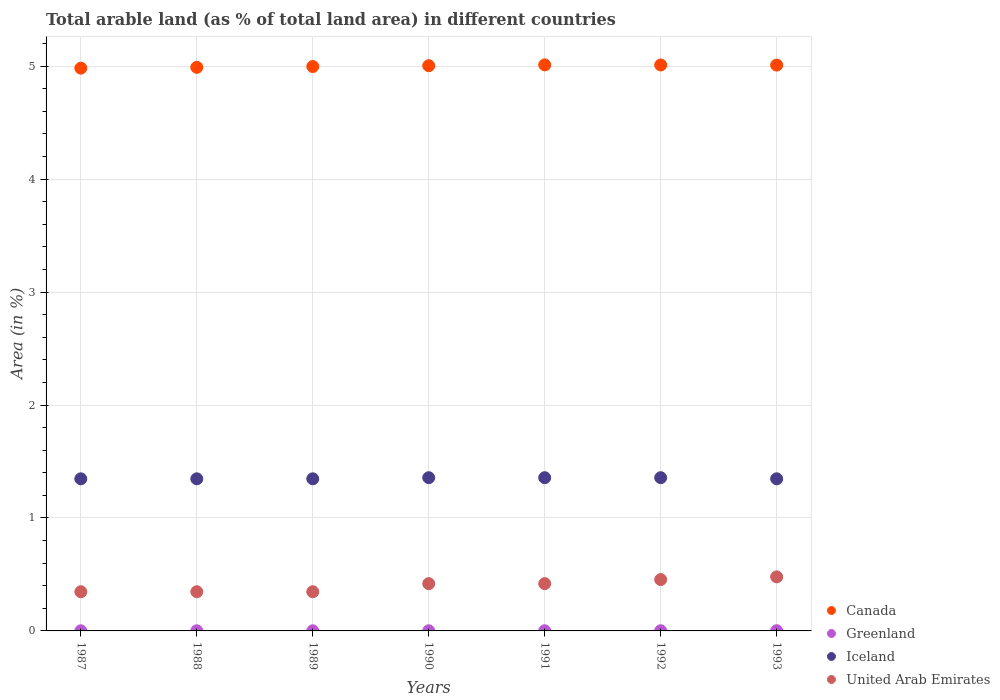How many different coloured dotlines are there?
Make the answer very short. 4. Is the number of dotlines equal to the number of legend labels?
Offer a very short reply. Yes. What is the percentage of arable land in Iceland in 1993?
Make the answer very short. 1.35. Across all years, what is the maximum percentage of arable land in Iceland?
Your answer should be very brief. 1.36. Across all years, what is the minimum percentage of arable land in United Arab Emirates?
Offer a very short reply. 0.35. In which year was the percentage of arable land in United Arab Emirates maximum?
Your response must be concise. 1993. In which year was the percentage of arable land in Canada minimum?
Your answer should be very brief. 1987. What is the total percentage of arable land in Iceland in the graph?
Keep it short and to the point. 9.46. What is the difference between the percentage of arable land in Canada in 1989 and that in 1992?
Keep it short and to the point. -0.01. What is the difference between the percentage of arable land in United Arab Emirates in 1989 and the percentage of arable land in Greenland in 1990?
Give a very brief answer. 0.35. What is the average percentage of arable land in Iceland per year?
Ensure brevity in your answer.  1.35. In the year 1993, what is the difference between the percentage of arable land in Greenland and percentage of arable land in Canada?
Provide a short and direct response. -5.01. In how many years, is the percentage of arable land in United Arab Emirates greater than 1.8 %?
Keep it short and to the point. 0. What is the ratio of the percentage of arable land in United Arab Emirates in 1989 to that in 1991?
Offer a terse response. 0.83. Is the difference between the percentage of arable land in Greenland in 1987 and 1989 greater than the difference between the percentage of arable land in Canada in 1987 and 1989?
Your response must be concise. Yes. What is the difference between the highest and the lowest percentage of arable land in Iceland?
Give a very brief answer. 0.01. Is it the case that in every year, the sum of the percentage of arable land in Canada and percentage of arable land in Iceland  is greater than the sum of percentage of arable land in United Arab Emirates and percentage of arable land in Greenland?
Your answer should be very brief. No. Does the percentage of arable land in Canada monotonically increase over the years?
Your answer should be compact. No. Is the percentage of arable land in Canada strictly less than the percentage of arable land in United Arab Emirates over the years?
Make the answer very short. No. How many years are there in the graph?
Your response must be concise. 7. What is the difference between two consecutive major ticks on the Y-axis?
Provide a short and direct response. 1. Are the values on the major ticks of Y-axis written in scientific E-notation?
Make the answer very short. No. Does the graph contain any zero values?
Your answer should be very brief. No. Does the graph contain grids?
Your response must be concise. Yes. What is the title of the graph?
Offer a very short reply. Total arable land (as % of total land area) in different countries. Does "High income: nonOECD" appear as one of the legend labels in the graph?
Offer a very short reply. No. What is the label or title of the X-axis?
Keep it short and to the point. Years. What is the label or title of the Y-axis?
Offer a very short reply. Area (in %). What is the Area (in %) of Canada in 1987?
Your response must be concise. 4.98. What is the Area (in %) in Greenland in 1987?
Your answer should be very brief. 0. What is the Area (in %) in Iceland in 1987?
Your answer should be compact. 1.35. What is the Area (in %) in United Arab Emirates in 1987?
Provide a succinct answer. 0.35. What is the Area (in %) in Canada in 1988?
Offer a terse response. 4.99. What is the Area (in %) in Greenland in 1988?
Provide a short and direct response. 0. What is the Area (in %) of Iceland in 1988?
Keep it short and to the point. 1.35. What is the Area (in %) in United Arab Emirates in 1988?
Make the answer very short. 0.35. What is the Area (in %) of Canada in 1989?
Make the answer very short. 5. What is the Area (in %) in Greenland in 1989?
Offer a terse response. 0. What is the Area (in %) in Iceland in 1989?
Your answer should be compact. 1.35. What is the Area (in %) in United Arab Emirates in 1989?
Give a very brief answer. 0.35. What is the Area (in %) of Canada in 1990?
Your answer should be compact. 5. What is the Area (in %) of Greenland in 1990?
Keep it short and to the point. 0. What is the Area (in %) in Iceland in 1990?
Ensure brevity in your answer.  1.36. What is the Area (in %) in United Arab Emirates in 1990?
Offer a terse response. 0.42. What is the Area (in %) in Canada in 1991?
Your answer should be compact. 5.01. What is the Area (in %) of Greenland in 1991?
Offer a terse response. 0. What is the Area (in %) in Iceland in 1991?
Keep it short and to the point. 1.36. What is the Area (in %) of United Arab Emirates in 1991?
Keep it short and to the point. 0.42. What is the Area (in %) of Canada in 1992?
Your response must be concise. 5.01. What is the Area (in %) in Greenland in 1992?
Provide a succinct answer. 0. What is the Area (in %) in Iceland in 1992?
Keep it short and to the point. 1.36. What is the Area (in %) of United Arab Emirates in 1992?
Make the answer very short. 0.45. What is the Area (in %) of Canada in 1993?
Your answer should be compact. 5.01. What is the Area (in %) of Greenland in 1993?
Your answer should be compact. 0. What is the Area (in %) of Iceland in 1993?
Provide a short and direct response. 1.35. What is the Area (in %) of United Arab Emirates in 1993?
Your response must be concise. 0.48. Across all years, what is the maximum Area (in %) of Canada?
Offer a terse response. 5.01. Across all years, what is the maximum Area (in %) in Greenland?
Provide a short and direct response. 0. Across all years, what is the maximum Area (in %) of Iceland?
Keep it short and to the point. 1.36. Across all years, what is the maximum Area (in %) of United Arab Emirates?
Your answer should be very brief. 0.48. Across all years, what is the minimum Area (in %) of Canada?
Your answer should be compact. 4.98. Across all years, what is the minimum Area (in %) of Greenland?
Offer a terse response. 0. Across all years, what is the minimum Area (in %) of Iceland?
Your answer should be very brief. 1.35. Across all years, what is the minimum Area (in %) in United Arab Emirates?
Provide a short and direct response. 0.35. What is the total Area (in %) of Canada in the graph?
Your response must be concise. 35. What is the total Area (in %) in Iceland in the graph?
Offer a terse response. 9.46. What is the total Area (in %) in United Arab Emirates in the graph?
Provide a succinct answer. 2.81. What is the difference between the Area (in %) of Canada in 1987 and that in 1988?
Offer a very short reply. -0.01. What is the difference between the Area (in %) in Greenland in 1987 and that in 1988?
Your response must be concise. 0. What is the difference between the Area (in %) of Canada in 1987 and that in 1989?
Provide a succinct answer. -0.01. What is the difference between the Area (in %) in Greenland in 1987 and that in 1989?
Offer a terse response. 0. What is the difference between the Area (in %) in Iceland in 1987 and that in 1989?
Provide a short and direct response. 0. What is the difference between the Area (in %) of Canada in 1987 and that in 1990?
Ensure brevity in your answer.  -0.02. What is the difference between the Area (in %) in Greenland in 1987 and that in 1990?
Give a very brief answer. -0. What is the difference between the Area (in %) of Iceland in 1987 and that in 1990?
Give a very brief answer. -0.01. What is the difference between the Area (in %) in United Arab Emirates in 1987 and that in 1990?
Give a very brief answer. -0.07. What is the difference between the Area (in %) in Canada in 1987 and that in 1991?
Ensure brevity in your answer.  -0.03. What is the difference between the Area (in %) in Greenland in 1987 and that in 1991?
Offer a terse response. -0. What is the difference between the Area (in %) of Iceland in 1987 and that in 1991?
Provide a succinct answer. -0.01. What is the difference between the Area (in %) of United Arab Emirates in 1987 and that in 1991?
Your answer should be very brief. -0.07. What is the difference between the Area (in %) of Canada in 1987 and that in 1992?
Offer a terse response. -0.03. What is the difference between the Area (in %) in Greenland in 1987 and that in 1992?
Your answer should be compact. -0. What is the difference between the Area (in %) of Iceland in 1987 and that in 1992?
Offer a terse response. -0.01. What is the difference between the Area (in %) in United Arab Emirates in 1987 and that in 1992?
Provide a short and direct response. -0.11. What is the difference between the Area (in %) in Canada in 1987 and that in 1993?
Your response must be concise. -0.03. What is the difference between the Area (in %) of Greenland in 1987 and that in 1993?
Provide a succinct answer. -0. What is the difference between the Area (in %) in United Arab Emirates in 1987 and that in 1993?
Ensure brevity in your answer.  -0.13. What is the difference between the Area (in %) in Canada in 1988 and that in 1989?
Your response must be concise. -0.01. What is the difference between the Area (in %) in Iceland in 1988 and that in 1989?
Provide a short and direct response. 0. What is the difference between the Area (in %) of United Arab Emirates in 1988 and that in 1989?
Ensure brevity in your answer.  0. What is the difference between the Area (in %) of Canada in 1988 and that in 1990?
Your answer should be very brief. -0.01. What is the difference between the Area (in %) in Greenland in 1988 and that in 1990?
Provide a succinct answer. -0. What is the difference between the Area (in %) in Iceland in 1988 and that in 1990?
Offer a very short reply. -0.01. What is the difference between the Area (in %) of United Arab Emirates in 1988 and that in 1990?
Provide a succinct answer. -0.07. What is the difference between the Area (in %) in Canada in 1988 and that in 1991?
Your response must be concise. -0.02. What is the difference between the Area (in %) in Greenland in 1988 and that in 1991?
Offer a very short reply. -0. What is the difference between the Area (in %) in Iceland in 1988 and that in 1991?
Your answer should be compact. -0.01. What is the difference between the Area (in %) in United Arab Emirates in 1988 and that in 1991?
Keep it short and to the point. -0.07. What is the difference between the Area (in %) of Canada in 1988 and that in 1992?
Offer a terse response. -0.02. What is the difference between the Area (in %) in Greenland in 1988 and that in 1992?
Offer a very short reply. -0. What is the difference between the Area (in %) of Iceland in 1988 and that in 1992?
Provide a succinct answer. -0.01. What is the difference between the Area (in %) of United Arab Emirates in 1988 and that in 1992?
Give a very brief answer. -0.11. What is the difference between the Area (in %) in Canada in 1988 and that in 1993?
Provide a short and direct response. -0.02. What is the difference between the Area (in %) in Greenland in 1988 and that in 1993?
Offer a very short reply. -0. What is the difference between the Area (in %) of United Arab Emirates in 1988 and that in 1993?
Provide a short and direct response. -0.13. What is the difference between the Area (in %) in Canada in 1989 and that in 1990?
Make the answer very short. -0.01. What is the difference between the Area (in %) in Greenland in 1989 and that in 1990?
Provide a succinct answer. -0. What is the difference between the Area (in %) in Iceland in 1989 and that in 1990?
Provide a short and direct response. -0.01. What is the difference between the Area (in %) of United Arab Emirates in 1989 and that in 1990?
Your answer should be very brief. -0.07. What is the difference between the Area (in %) of Canada in 1989 and that in 1991?
Offer a terse response. -0.01. What is the difference between the Area (in %) in Greenland in 1989 and that in 1991?
Offer a terse response. -0. What is the difference between the Area (in %) of Iceland in 1989 and that in 1991?
Provide a succinct answer. -0.01. What is the difference between the Area (in %) in United Arab Emirates in 1989 and that in 1991?
Your answer should be very brief. -0.07. What is the difference between the Area (in %) of Canada in 1989 and that in 1992?
Provide a short and direct response. -0.01. What is the difference between the Area (in %) of Greenland in 1989 and that in 1992?
Your response must be concise. -0. What is the difference between the Area (in %) of Iceland in 1989 and that in 1992?
Offer a terse response. -0.01. What is the difference between the Area (in %) in United Arab Emirates in 1989 and that in 1992?
Give a very brief answer. -0.11. What is the difference between the Area (in %) in Canada in 1989 and that in 1993?
Offer a very short reply. -0.01. What is the difference between the Area (in %) in Greenland in 1989 and that in 1993?
Your answer should be very brief. -0. What is the difference between the Area (in %) in Iceland in 1989 and that in 1993?
Keep it short and to the point. 0. What is the difference between the Area (in %) in United Arab Emirates in 1989 and that in 1993?
Your answer should be very brief. -0.13. What is the difference between the Area (in %) of Canada in 1990 and that in 1991?
Give a very brief answer. -0.01. What is the difference between the Area (in %) of Greenland in 1990 and that in 1991?
Your response must be concise. 0. What is the difference between the Area (in %) of Canada in 1990 and that in 1992?
Provide a succinct answer. -0.01. What is the difference between the Area (in %) of Greenland in 1990 and that in 1992?
Your answer should be compact. -0. What is the difference between the Area (in %) of Iceland in 1990 and that in 1992?
Your answer should be very brief. 0. What is the difference between the Area (in %) of United Arab Emirates in 1990 and that in 1992?
Your answer should be very brief. -0.04. What is the difference between the Area (in %) in Canada in 1990 and that in 1993?
Make the answer very short. -0.01. What is the difference between the Area (in %) in Greenland in 1990 and that in 1993?
Give a very brief answer. -0. What is the difference between the Area (in %) of Iceland in 1990 and that in 1993?
Offer a terse response. 0.01. What is the difference between the Area (in %) in United Arab Emirates in 1990 and that in 1993?
Provide a short and direct response. -0.06. What is the difference between the Area (in %) in Canada in 1991 and that in 1992?
Your answer should be compact. 0. What is the difference between the Area (in %) in Greenland in 1991 and that in 1992?
Your answer should be compact. -0. What is the difference between the Area (in %) of Iceland in 1991 and that in 1992?
Give a very brief answer. 0. What is the difference between the Area (in %) in United Arab Emirates in 1991 and that in 1992?
Provide a succinct answer. -0.04. What is the difference between the Area (in %) of Canada in 1991 and that in 1993?
Provide a succinct answer. 0. What is the difference between the Area (in %) of Greenland in 1991 and that in 1993?
Your response must be concise. -0. What is the difference between the Area (in %) in United Arab Emirates in 1991 and that in 1993?
Keep it short and to the point. -0.06. What is the difference between the Area (in %) in Canada in 1992 and that in 1993?
Offer a very short reply. 0. What is the difference between the Area (in %) of Greenland in 1992 and that in 1993?
Your answer should be compact. 0. What is the difference between the Area (in %) in United Arab Emirates in 1992 and that in 1993?
Provide a short and direct response. -0.02. What is the difference between the Area (in %) of Canada in 1987 and the Area (in %) of Greenland in 1988?
Offer a terse response. 4.98. What is the difference between the Area (in %) in Canada in 1987 and the Area (in %) in Iceland in 1988?
Make the answer very short. 3.64. What is the difference between the Area (in %) of Canada in 1987 and the Area (in %) of United Arab Emirates in 1988?
Keep it short and to the point. 4.64. What is the difference between the Area (in %) in Greenland in 1987 and the Area (in %) in Iceland in 1988?
Your answer should be very brief. -1.35. What is the difference between the Area (in %) in Greenland in 1987 and the Area (in %) in United Arab Emirates in 1988?
Ensure brevity in your answer.  -0.35. What is the difference between the Area (in %) of Iceland in 1987 and the Area (in %) of United Arab Emirates in 1988?
Give a very brief answer. 1. What is the difference between the Area (in %) in Canada in 1987 and the Area (in %) in Greenland in 1989?
Offer a terse response. 4.98. What is the difference between the Area (in %) of Canada in 1987 and the Area (in %) of Iceland in 1989?
Provide a short and direct response. 3.64. What is the difference between the Area (in %) of Canada in 1987 and the Area (in %) of United Arab Emirates in 1989?
Make the answer very short. 4.64. What is the difference between the Area (in %) in Greenland in 1987 and the Area (in %) in Iceland in 1989?
Offer a very short reply. -1.35. What is the difference between the Area (in %) of Greenland in 1987 and the Area (in %) of United Arab Emirates in 1989?
Your response must be concise. -0.35. What is the difference between the Area (in %) of Canada in 1987 and the Area (in %) of Greenland in 1990?
Offer a terse response. 4.98. What is the difference between the Area (in %) in Canada in 1987 and the Area (in %) in Iceland in 1990?
Your answer should be very brief. 3.63. What is the difference between the Area (in %) of Canada in 1987 and the Area (in %) of United Arab Emirates in 1990?
Your answer should be compact. 4.56. What is the difference between the Area (in %) of Greenland in 1987 and the Area (in %) of Iceland in 1990?
Make the answer very short. -1.36. What is the difference between the Area (in %) in Greenland in 1987 and the Area (in %) in United Arab Emirates in 1990?
Give a very brief answer. -0.42. What is the difference between the Area (in %) in Iceland in 1987 and the Area (in %) in United Arab Emirates in 1990?
Your response must be concise. 0.93. What is the difference between the Area (in %) of Canada in 1987 and the Area (in %) of Greenland in 1991?
Your response must be concise. 4.98. What is the difference between the Area (in %) of Canada in 1987 and the Area (in %) of Iceland in 1991?
Your answer should be compact. 3.63. What is the difference between the Area (in %) in Canada in 1987 and the Area (in %) in United Arab Emirates in 1991?
Your answer should be compact. 4.56. What is the difference between the Area (in %) of Greenland in 1987 and the Area (in %) of Iceland in 1991?
Offer a very short reply. -1.36. What is the difference between the Area (in %) in Greenland in 1987 and the Area (in %) in United Arab Emirates in 1991?
Offer a terse response. -0.42. What is the difference between the Area (in %) of Iceland in 1987 and the Area (in %) of United Arab Emirates in 1991?
Make the answer very short. 0.93. What is the difference between the Area (in %) of Canada in 1987 and the Area (in %) of Greenland in 1992?
Ensure brevity in your answer.  4.98. What is the difference between the Area (in %) of Canada in 1987 and the Area (in %) of Iceland in 1992?
Offer a terse response. 3.63. What is the difference between the Area (in %) in Canada in 1987 and the Area (in %) in United Arab Emirates in 1992?
Make the answer very short. 4.53. What is the difference between the Area (in %) of Greenland in 1987 and the Area (in %) of Iceland in 1992?
Provide a succinct answer. -1.36. What is the difference between the Area (in %) in Greenland in 1987 and the Area (in %) in United Arab Emirates in 1992?
Offer a very short reply. -0.45. What is the difference between the Area (in %) in Iceland in 1987 and the Area (in %) in United Arab Emirates in 1992?
Keep it short and to the point. 0.89. What is the difference between the Area (in %) in Canada in 1987 and the Area (in %) in Greenland in 1993?
Give a very brief answer. 4.98. What is the difference between the Area (in %) of Canada in 1987 and the Area (in %) of Iceland in 1993?
Offer a very short reply. 3.64. What is the difference between the Area (in %) in Canada in 1987 and the Area (in %) in United Arab Emirates in 1993?
Give a very brief answer. 4.5. What is the difference between the Area (in %) of Greenland in 1987 and the Area (in %) of Iceland in 1993?
Provide a succinct answer. -1.35. What is the difference between the Area (in %) of Greenland in 1987 and the Area (in %) of United Arab Emirates in 1993?
Provide a short and direct response. -0.48. What is the difference between the Area (in %) in Iceland in 1987 and the Area (in %) in United Arab Emirates in 1993?
Ensure brevity in your answer.  0.87. What is the difference between the Area (in %) in Canada in 1988 and the Area (in %) in Greenland in 1989?
Your answer should be compact. 4.99. What is the difference between the Area (in %) in Canada in 1988 and the Area (in %) in Iceland in 1989?
Your response must be concise. 3.64. What is the difference between the Area (in %) of Canada in 1988 and the Area (in %) of United Arab Emirates in 1989?
Provide a short and direct response. 4.64. What is the difference between the Area (in %) in Greenland in 1988 and the Area (in %) in Iceland in 1989?
Offer a very short reply. -1.35. What is the difference between the Area (in %) in Greenland in 1988 and the Area (in %) in United Arab Emirates in 1989?
Make the answer very short. -0.35. What is the difference between the Area (in %) of Iceland in 1988 and the Area (in %) of United Arab Emirates in 1989?
Offer a terse response. 1. What is the difference between the Area (in %) in Canada in 1988 and the Area (in %) in Greenland in 1990?
Keep it short and to the point. 4.99. What is the difference between the Area (in %) of Canada in 1988 and the Area (in %) of Iceland in 1990?
Keep it short and to the point. 3.63. What is the difference between the Area (in %) in Canada in 1988 and the Area (in %) in United Arab Emirates in 1990?
Keep it short and to the point. 4.57. What is the difference between the Area (in %) of Greenland in 1988 and the Area (in %) of Iceland in 1990?
Your answer should be very brief. -1.36. What is the difference between the Area (in %) in Greenland in 1988 and the Area (in %) in United Arab Emirates in 1990?
Give a very brief answer. -0.42. What is the difference between the Area (in %) of Iceland in 1988 and the Area (in %) of United Arab Emirates in 1990?
Provide a short and direct response. 0.93. What is the difference between the Area (in %) of Canada in 1988 and the Area (in %) of Greenland in 1991?
Your answer should be compact. 4.99. What is the difference between the Area (in %) of Canada in 1988 and the Area (in %) of Iceland in 1991?
Provide a short and direct response. 3.63. What is the difference between the Area (in %) of Canada in 1988 and the Area (in %) of United Arab Emirates in 1991?
Make the answer very short. 4.57. What is the difference between the Area (in %) of Greenland in 1988 and the Area (in %) of Iceland in 1991?
Give a very brief answer. -1.36. What is the difference between the Area (in %) of Greenland in 1988 and the Area (in %) of United Arab Emirates in 1991?
Your answer should be compact. -0.42. What is the difference between the Area (in %) in Iceland in 1988 and the Area (in %) in United Arab Emirates in 1991?
Your response must be concise. 0.93. What is the difference between the Area (in %) of Canada in 1988 and the Area (in %) of Greenland in 1992?
Your answer should be compact. 4.99. What is the difference between the Area (in %) in Canada in 1988 and the Area (in %) in Iceland in 1992?
Provide a succinct answer. 3.63. What is the difference between the Area (in %) of Canada in 1988 and the Area (in %) of United Arab Emirates in 1992?
Provide a succinct answer. 4.53. What is the difference between the Area (in %) of Greenland in 1988 and the Area (in %) of Iceland in 1992?
Your answer should be compact. -1.36. What is the difference between the Area (in %) in Greenland in 1988 and the Area (in %) in United Arab Emirates in 1992?
Provide a short and direct response. -0.45. What is the difference between the Area (in %) in Iceland in 1988 and the Area (in %) in United Arab Emirates in 1992?
Give a very brief answer. 0.89. What is the difference between the Area (in %) in Canada in 1988 and the Area (in %) in Greenland in 1993?
Your answer should be compact. 4.99. What is the difference between the Area (in %) in Canada in 1988 and the Area (in %) in Iceland in 1993?
Give a very brief answer. 3.64. What is the difference between the Area (in %) of Canada in 1988 and the Area (in %) of United Arab Emirates in 1993?
Keep it short and to the point. 4.51. What is the difference between the Area (in %) of Greenland in 1988 and the Area (in %) of Iceland in 1993?
Your answer should be very brief. -1.35. What is the difference between the Area (in %) in Greenland in 1988 and the Area (in %) in United Arab Emirates in 1993?
Provide a short and direct response. -0.48. What is the difference between the Area (in %) in Iceland in 1988 and the Area (in %) in United Arab Emirates in 1993?
Offer a very short reply. 0.87. What is the difference between the Area (in %) of Canada in 1989 and the Area (in %) of Greenland in 1990?
Ensure brevity in your answer.  5. What is the difference between the Area (in %) in Canada in 1989 and the Area (in %) in Iceland in 1990?
Provide a succinct answer. 3.64. What is the difference between the Area (in %) of Canada in 1989 and the Area (in %) of United Arab Emirates in 1990?
Offer a terse response. 4.58. What is the difference between the Area (in %) in Greenland in 1989 and the Area (in %) in Iceland in 1990?
Give a very brief answer. -1.36. What is the difference between the Area (in %) in Greenland in 1989 and the Area (in %) in United Arab Emirates in 1990?
Provide a succinct answer. -0.42. What is the difference between the Area (in %) in Iceland in 1989 and the Area (in %) in United Arab Emirates in 1990?
Provide a short and direct response. 0.93. What is the difference between the Area (in %) of Canada in 1989 and the Area (in %) of Greenland in 1991?
Offer a very short reply. 5. What is the difference between the Area (in %) of Canada in 1989 and the Area (in %) of Iceland in 1991?
Make the answer very short. 3.64. What is the difference between the Area (in %) of Canada in 1989 and the Area (in %) of United Arab Emirates in 1991?
Your answer should be very brief. 4.58. What is the difference between the Area (in %) in Greenland in 1989 and the Area (in %) in Iceland in 1991?
Give a very brief answer. -1.36. What is the difference between the Area (in %) of Greenland in 1989 and the Area (in %) of United Arab Emirates in 1991?
Give a very brief answer. -0.42. What is the difference between the Area (in %) of Iceland in 1989 and the Area (in %) of United Arab Emirates in 1991?
Keep it short and to the point. 0.93. What is the difference between the Area (in %) in Canada in 1989 and the Area (in %) in Greenland in 1992?
Provide a succinct answer. 5. What is the difference between the Area (in %) in Canada in 1989 and the Area (in %) in Iceland in 1992?
Provide a succinct answer. 3.64. What is the difference between the Area (in %) in Canada in 1989 and the Area (in %) in United Arab Emirates in 1992?
Provide a short and direct response. 4.54. What is the difference between the Area (in %) of Greenland in 1989 and the Area (in %) of Iceland in 1992?
Your response must be concise. -1.36. What is the difference between the Area (in %) of Greenland in 1989 and the Area (in %) of United Arab Emirates in 1992?
Your answer should be compact. -0.45. What is the difference between the Area (in %) in Iceland in 1989 and the Area (in %) in United Arab Emirates in 1992?
Provide a short and direct response. 0.89. What is the difference between the Area (in %) of Canada in 1989 and the Area (in %) of Greenland in 1993?
Provide a succinct answer. 5. What is the difference between the Area (in %) in Canada in 1989 and the Area (in %) in Iceland in 1993?
Ensure brevity in your answer.  3.65. What is the difference between the Area (in %) of Canada in 1989 and the Area (in %) of United Arab Emirates in 1993?
Give a very brief answer. 4.52. What is the difference between the Area (in %) in Greenland in 1989 and the Area (in %) in Iceland in 1993?
Ensure brevity in your answer.  -1.35. What is the difference between the Area (in %) of Greenland in 1989 and the Area (in %) of United Arab Emirates in 1993?
Your response must be concise. -0.48. What is the difference between the Area (in %) in Iceland in 1989 and the Area (in %) in United Arab Emirates in 1993?
Make the answer very short. 0.87. What is the difference between the Area (in %) in Canada in 1990 and the Area (in %) in Greenland in 1991?
Your response must be concise. 5. What is the difference between the Area (in %) of Canada in 1990 and the Area (in %) of Iceland in 1991?
Offer a very short reply. 3.65. What is the difference between the Area (in %) in Canada in 1990 and the Area (in %) in United Arab Emirates in 1991?
Provide a succinct answer. 4.59. What is the difference between the Area (in %) in Greenland in 1990 and the Area (in %) in Iceland in 1991?
Make the answer very short. -1.36. What is the difference between the Area (in %) of Greenland in 1990 and the Area (in %) of United Arab Emirates in 1991?
Offer a terse response. -0.42. What is the difference between the Area (in %) in Iceland in 1990 and the Area (in %) in United Arab Emirates in 1991?
Offer a terse response. 0.94. What is the difference between the Area (in %) of Canada in 1990 and the Area (in %) of Greenland in 1992?
Keep it short and to the point. 5. What is the difference between the Area (in %) of Canada in 1990 and the Area (in %) of Iceland in 1992?
Make the answer very short. 3.65. What is the difference between the Area (in %) of Canada in 1990 and the Area (in %) of United Arab Emirates in 1992?
Provide a succinct answer. 4.55. What is the difference between the Area (in %) in Greenland in 1990 and the Area (in %) in Iceland in 1992?
Offer a terse response. -1.36. What is the difference between the Area (in %) in Greenland in 1990 and the Area (in %) in United Arab Emirates in 1992?
Make the answer very short. -0.45. What is the difference between the Area (in %) of Iceland in 1990 and the Area (in %) of United Arab Emirates in 1992?
Give a very brief answer. 0.9. What is the difference between the Area (in %) in Canada in 1990 and the Area (in %) in Greenland in 1993?
Give a very brief answer. 5. What is the difference between the Area (in %) in Canada in 1990 and the Area (in %) in Iceland in 1993?
Keep it short and to the point. 3.66. What is the difference between the Area (in %) in Canada in 1990 and the Area (in %) in United Arab Emirates in 1993?
Keep it short and to the point. 4.53. What is the difference between the Area (in %) in Greenland in 1990 and the Area (in %) in Iceland in 1993?
Your answer should be very brief. -1.35. What is the difference between the Area (in %) in Greenland in 1990 and the Area (in %) in United Arab Emirates in 1993?
Keep it short and to the point. -0.48. What is the difference between the Area (in %) in Iceland in 1990 and the Area (in %) in United Arab Emirates in 1993?
Offer a terse response. 0.88. What is the difference between the Area (in %) in Canada in 1991 and the Area (in %) in Greenland in 1992?
Your answer should be very brief. 5.01. What is the difference between the Area (in %) in Canada in 1991 and the Area (in %) in Iceland in 1992?
Offer a terse response. 3.65. What is the difference between the Area (in %) in Canada in 1991 and the Area (in %) in United Arab Emirates in 1992?
Ensure brevity in your answer.  4.56. What is the difference between the Area (in %) in Greenland in 1991 and the Area (in %) in Iceland in 1992?
Give a very brief answer. -1.36. What is the difference between the Area (in %) in Greenland in 1991 and the Area (in %) in United Arab Emirates in 1992?
Give a very brief answer. -0.45. What is the difference between the Area (in %) in Iceland in 1991 and the Area (in %) in United Arab Emirates in 1992?
Your answer should be compact. 0.9. What is the difference between the Area (in %) in Canada in 1991 and the Area (in %) in Greenland in 1993?
Provide a short and direct response. 5.01. What is the difference between the Area (in %) in Canada in 1991 and the Area (in %) in Iceland in 1993?
Give a very brief answer. 3.66. What is the difference between the Area (in %) of Canada in 1991 and the Area (in %) of United Arab Emirates in 1993?
Ensure brevity in your answer.  4.53. What is the difference between the Area (in %) in Greenland in 1991 and the Area (in %) in Iceland in 1993?
Ensure brevity in your answer.  -1.35. What is the difference between the Area (in %) of Greenland in 1991 and the Area (in %) of United Arab Emirates in 1993?
Provide a short and direct response. -0.48. What is the difference between the Area (in %) of Iceland in 1991 and the Area (in %) of United Arab Emirates in 1993?
Make the answer very short. 0.88. What is the difference between the Area (in %) of Canada in 1992 and the Area (in %) of Greenland in 1993?
Your response must be concise. 5.01. What is the difference between the Area (in %) in Canada in 1992 and the Area (in %) in Iceland in 1993?
Offer a very short reply. 3.66. What is the difference between the Area (in %) of Canada in 1992 and the Area (in %) of United Arab Emirates in 1993?
Keep it short and to the point. 4.53. What is the difference between the Area (in %) in Greenland in 1992 and the Area (in %) in Iceland in 1993?
Offer a terse response. -1.34. What is the difference between the Area (in %) of Greenland in 1992 and the Area (in %) of United Arab Emirates in 1993?
Offer a very short reply. -0.48. What is the difference between the Area (in %) in Iceland in 1992 and the Area (in %) in United Arab Emirates in 1993?
Offer a very short reply. 0.88. What is the average Area (in %) in Canada per year?
Keep it short and to the point. 5. What is the average Area (in %) in Greenland per year?
Your answer should be compact. 0. What is the average Area (in %) in Iceland per year?
Provide a short and direct response. 1.35. What is the average Area (in %) in United Arab Emirates per year?
Ensure brevity in your answer.  0.4. In the year 1987, what is the difference between the Area (in %) in Canada and Area (in %) in Greenland?
Keep it short and to the point. 4.98. In the year 1987, what is the difference between the Area (in %) in Canada and Area (in %) in Iceland?
Offer a very short reply. 3.64. In the year 1987, what is the difference between the Area (in %) of Canada and Area (in %) of United Arab Emirates?
Your answer should be very brief. 4.64. In the year 1987, what is the difference between the Area (in %) in Greenland and Area (in %) in Iceland?
Keep it short and to the point. -1.35. In the year 1987, what is the difference between the Area (in %) of Greenland and Area (in %) of United Arab Emirates?
Offer a very short reply. -0.35. In the year 1987, what is the difference between the Area (in %) of Iceland and Area (in %) of United Arab Emirates?
Keep it short and to the point. 1. In the year 1988, what is the difference between the Area (in %) in Canada and Area (in %) in Greenland?
Your answer should be compact. 4.99. In the year 1988, what is the difference between the Area (in %) in Canada and Area (in %) in Iceland?
Offer a terse response. 3.64. In the year 1988, what is the difference between the Area (in %) in Canada and Area (in %) in United Arab Emirates?
Give a very brief answer. 4.64. In the year 1988, what is the difference between the Area (in %) in Greenland and Area (in %) in Iceland?
Provide a short and direct response. -1.35. In the year 1988, what is the difference between the Area (in %) of Greenland and Area (in %) of United Arab Emirates?
Ensure brevity in your answer.  -0.35. In the year 1988, what is the difference between the Area (in %) of Iceland and Area (in %) of United Arab Emirates?
Provide a succinct answer. 1. In the year 1989, what is the difference between the Area (in %) in Canada and Area (in %) in Greenland?
Your answer should be compact. 5. In the year 1989, what is the difference between the Area (in %) in Canada and Area (in %) in Iceland?
Your answer should be very brief. 3.65. In the year 1989, what is the difference between the Area (in %) of Canada and Area (in %) of United Arab Emirates?
Your answer should be compact. 4.65. In the year 1989, what is the difference between the Area (in %) in Greenland and Area (in %) in Iceland?
Offer a terse response. -1.35. In the year 1989, what is the difference between the Area (in %) in Greenland and Area (in %) in United Arab Emirates?
Your answer should be compact. -0.35. In the year 1989, what is the difference between the Area (in %) of Iceland and Area (in %) of United Arab Emirates?
Provide a short and direct response. 1. In the year 1990, what is the difference between the Area (in %) of Canada and Area (in %) of Greenland?
Provide a succinct answer. 5. In the year 1990, what is the difference between the Area (in %) in Canada and Area (in %) in Iceland?
Your answer should be compact. 3.65. In the year 1990, what is the difference between the Area (in %) in Canada and Area (in %) in United Arab Emirates?
Ensure brevity in your answer.  4.59. In the year 1990, what is the difference between the Area (in %) in Greenland and Area (in %) in Iceland?
Make the answer very short. -1.36. In the year 1990, what is the difference between the Area (in %) of Greenland and Area (in %) of United Arab Emirates?
Provide a succinct answer. -0.42. In the year 1990, what is the difference between the Area (in %) of Iceland and Area (in %) of United Arab Emirates?
Keep it short and to the point. 0.94. In the year 1991, what is the difference between the Area (in %) of Canada and Area (in %) of Greenland?
Provide a short and direct response. 5.01. In the year 1991, what is the difference between the Area (in %) in Canada and Area (in %) in Iceland?
Give a very brief answer. 3.65. In the year 1991, what is the difference between the Area (in %) in Canada and Area (in %) in United Arab Emirates?
Provide a short and direct response. 4.59. In the year 1991, what is the difference between the Area (in %) in Greenland and Area (in %) in Iceland?
Make the answer very short. -1.36. In the year 1991, what is the difference between the Area (in %) in Greenland and Area (in %) in United Arab Emirates?
Provide a short and direct response. -0.42. In the year 1991, what is the difference between the Area (in %) of Iceland and Area (in %) of United Arab Emirates?
Your response must be concise. 0.94. In the year 1992, what is the difference between the Area (in %) in Canada and Area (in %) in Greenland?
Give a very brief answer. 5.01. In the year 1992, what is the difference between the Area (in %) of Canada and Area (in %) of Iceland?
Provide a short and direct response. 3.65. In the year 1992, what is the difference between the Area (in %) of Canada and Area (in %) of United Arab Emirates?
Offer a very short reply. 4.56. In the year 1992, what is the difference between the Area (in %) of Greenland and Area (in %) of Iceland?
Provide a short and direct response. -1.35. In the year 1992, what is the difference between the Area (in %) of Greenland and Area (in %) of United Arab Emirates?
Offer a very short reply. -0.45. In the year 1992, what is the difference between the Area (in %) in Iceland and Area (in %) in United Arab Emirates?
Give a very brief answer. 0.9. In the year 1993, what is the difference between the Area (in %) in Canada and Area (in %) in Greenland?
Your response must be concise. 5.01. In the year 1993, what is the difference between the Area (in %) of Canada and Area (in %) of Iceland?
Your answer should be compact. 3.66. In the year 1993, what is the difference between the Area (in %) of Canada and Area (in %) of United Arab Emirates?
Your response must be concise. 4.53. In the year 1993, what is the difference between the Area (in %) in Greenland and Area (in %) in Iceland?
Ensure brevity in your answer.  -1.34. In the year 1993, what is the difference between the Area (in %) of Greenland and Area (in %) of United Arab Emirates?
Your answer should be compact. -0.48. In the year 1993, what is the difference between the Area (in %) in Iceland and Area (in %) in United Arab Emirates?
Keep it short and to the point. 0.87. What is the ratio of the Area (in %) of Greenland in 1987 to that in 1988?
Give a very brief answer. 1. What is the ratio of the Area (in %) in Iceland in 1987 to that in 1988?
Offer a very short reply. 1. What is the ratio of the Area (in %) in Canada in 1987 to that in 1989?
Offer a very short reply. 1. What is the ratio of the Area (in %) of Greenland in 1987 to that in 1989?
Provide a short and direct response. 1. What is the ratio of the Area (in %) of Iceland in 1987 to that in 1989?
Give a very brief answer. 1. What is the ratio of the Area (in %) of Greenland in 1987 to that in 1990?
Your answer should be compact. 0.8. What is the ratio of the Area (in %) of United Arab Emirates in 1987 to that in 1990?
Offer a terse response. 0.83. What is the ratio of the Area (in %) in Iceland in 1987 to that in 1991?
Make the answer very short. 0.99. What is the ratio of the Area (in %) in United Arab Emirates in 1987 to that in 1991?
Offer a very short reply. 0.83. What is the ratio of the Area (in %) in Iceland in 1987 to that in 1992?
Make the answer very short. 0.99. What is the ratio of the Area (in %) of United Arab Emirates in 1987 to that in 1992?
Provide a succinct answer. 0.76. What is the ratio of the Area (in %) in Canada in 1987 to that in 1993?
Offer a terse response. 0.99. What is the ratio of the Area (in %) of United Arab Emirates in 1987 to that in 1993?
Give a very brief answer. 0.72. What is the ratio of the Area (in %) of Canada in 1988 to that in 1989?
Your response must be concise. 1. What is the ratio of the Area (in %) in Iceland in 1988 to that in 1989?
Provide a succinct answer. 1. What is the ratio of the Area (in %) of Greenland in 1988 to that in 1990?
Provide a succinct answer. 0.8. What is the ratio of the Area (in %) in Iceland in 1988 to that in 1990?
Your answer should be very brief. 0.99. What is the ratio of the Area (in %) of United Arab Emirates in 1988 to that in 1990?
Provide a short and direct response. 0.83. What is the ratio of the Area (in %) in Canada in 1988 to that in 1991?
Your answer should be very brief. 1. What is the ratio of the Area (in %) in Greenland in 1988 to that in 1991?
Give a very brief answer. 0.8. What is the ratio of the Area (in %) of Iceland in 1988 to that in 1991?
Provide a short and direct response. 0.99. What is the ratio of the Area (in %) in United Arab Emirates in 1988 to that in 1991?
Provide a short and direct response. 0.83. What is the ratio of the Area (in %) in Iceland in 1988 to that in 1992?
Ensure brevity in your answer.  0.99. What is the ratio of the Area (in %) in United Arab Emirates in 1988 to that in 1992?
Your response must be concise. 0.76. What is the ratio of the Area (in %) in Iceland in 1988 to that in 1993?
Offer a very short reply. 1. What is the ratio of the Area (in %) of United Arab Emirates in 1988 to that in 1993?
Ensure brevity in your answer.  0.72. What is the ratio of the Area (in %) in United Arab Emirates in 1989 to that in 1990?
Your response must be concise. 0.83. What is the ratio of the Area (in %) of Iceland in 1989 to that in 1991?
Give a very brief answer. 0.99. What is the ratio of the Area (in %) in United Arab Emirates in 1989 to that in 1991?
Offer a terse response. 0.83. What is the ratio of the Area (in %) in Canada in 1989 to that in 1992?
Provide a short and direct response. 1. What is the ratio of the Area (in %) in United Arab Emirates in 1989 to that in 1992?
Provide a short and direct response. 0.76. What is the ratio of the Area (in %) of Canada in 1989 to that in 1993?
Keep it short and to the point. 1. What is the ratio of the Area (in %) of Greenland in 1989 to that in 1993?
Give a very brief answer. 0.67. What is the ratio of the Area (in %) of United Arab Emirates in 1989 to that in 1993?
Provide a short and direct response. 0.72. What is the ratio of the Area (in %) in Canada in 1990 to that in 1991?
Make the answer very short. 1. What is the ratio of the Area (in %) of Iceland in 1990 to that in 1991?
Ensure brevity in your answer.  1. What is the ratio of the Area (in %) in United Arab Emirates in 1990 to that in 1991?
Provide a short and direct response. 1. What is the ratio of the Area (in %) in Canada in 1990 to that in 1992?
Provide a succinct answer. 1. What is the ratio of the Area (in %) of United Arab Emirates in 1990 to that in 1992?
Offer a very short reply. 0.92. What is the ratio of the Area (in %) of Canada in 1990 to that in 1993?
Offer a very short reply. 1. What is the ratio of the Area (in %) of Greenland in 1990 to that in 1993?
Give a very brief answer. 0.83. What is the ratio of the Area (in %) of Iceland in 1990 to that in 1993?
Keep it short and to the point. 1.01. What is the ratio of the Area (in %) in United Arab Emirates in 1990 to that in 1993?
Keep it short and to the point. 0.88. What is the ratio of the Area (in %) in Canada in 1991 to that in 1992?
Offer a very short reply. 1. What is the ratio of the Area (in %) in United Arab Emirates in 1991 to that in 1992?
Provide a short and direct response. 0.92. What is the ratio of the Area (in %) in Canada in 1991 to that in 1993?
Ensure brevity in your answer.  1. What is the ratio of the Area (in %) in Iceland in 1991 to that in 1993?
Give a very brief answer. 1.01. What is the ratio of the Area (in %) in Canada in 1992 to that in 1993?
Make the answer very short. 1. What is the ratio of the Area (in %) of Iceland in 1992 to that in 1993?
Keep it short and to the point. 1.01. What is the difference between the highest and the second highest Area (in %) in Canada?
Your answer should be very brief. 0. What is the difference between the highest and the second highest Area (in %) of United Arab Emirates?
Your answer should be compact. 0.02. What is the difference between the highest and the lowest Area (in %) of Canada?
Your answer should be compact. 0.03. What is the difference between the highest and the lowest Area (in %) in Greenland?
Give a very brief answer. 0. What is the difference between the highest and the lowest Area (in %) of Iceland?
Your response must be concise. 0.01. What is the difference between the highest and the lowest Area (in %) in United Arab Emirates?
Give a very brief answer. 0.13. 